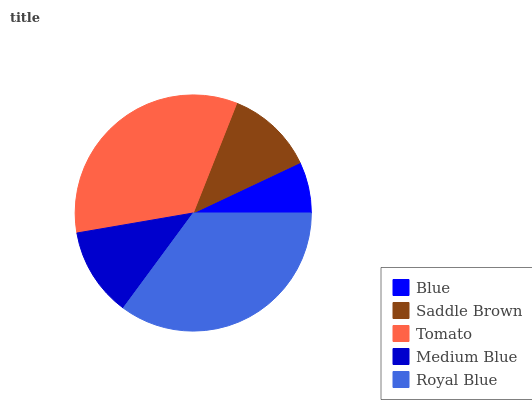Is Blue the minimum?
Answer yes or no. Yes. Is Royal Blue the maximum?
Answer yes or no. Yes. Is Saddle Brown the minimum?
Answer yes or no. No. Is Saddle Brown the maximum?
Answer yes or no. No. Is Saddle Brown greater than Blue?
Answer yes or no. Yes. Is Blue less than Saddle Brown?
Answer yes or no. Yes. Is Blue greater than Saddle Brown?
Answer yes or no. No. Is Saddle Brown less than Blue?
Answer yes or no. No. Is Medium Blue the high median?
Answer yes or no. Yes. Is Medium Blue the low median?
Answer yes or no. Yes. Is Royal Blue the high median?
Answer yes or no. No. Is Royal Blue the low median?
Answer yes or no. No. 